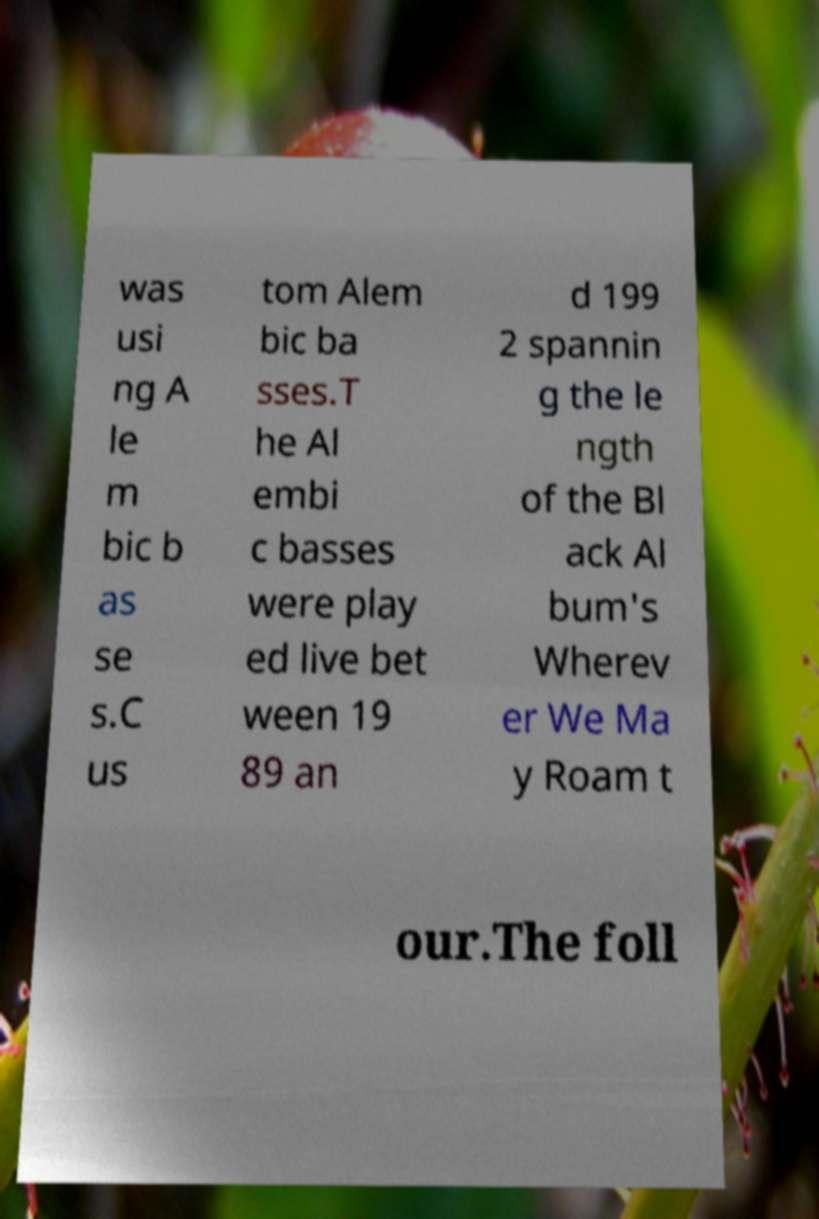For documentation purposes, I need the text within this image transcribed. Could you provide that? was usi ng A le m bic b as se s.C us tom Alem bic ba sses.T he Al embi c basses were play ed live bet ween 19 89 an d 199 2 spannin g the le ngth of the Bl ack Al bum's Wherev er We Ma y Roam t our.The foll 